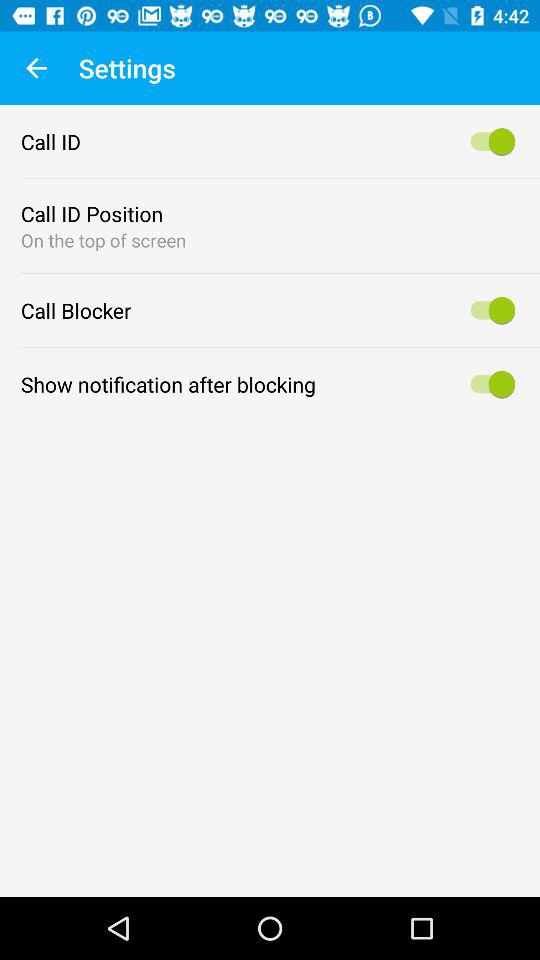What's the status of the "Show notification after blocking"? The status of the "Show notification after blocking" is "on". 